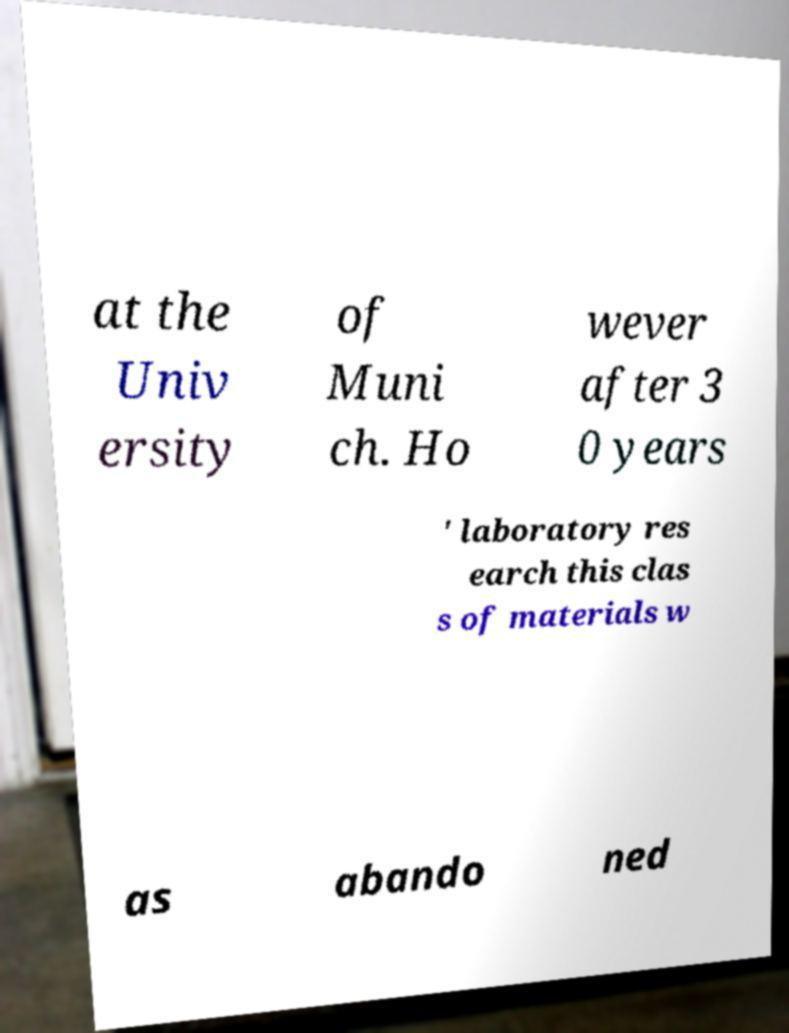Can you read and provide the text displayed in the image?This photo seems to have some interesting text. Can you extract and type it out for me? at the Univ ersity of Muni ch. Ho wever after 3 0 years ' laboratory res earch this clas s of materials w as abando ned 